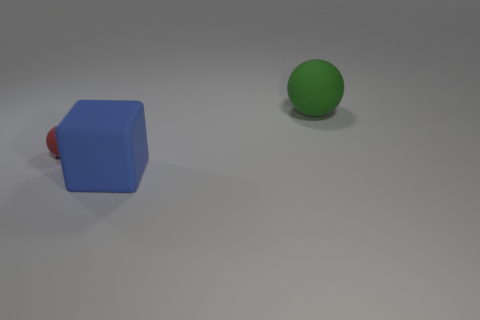There is another red ball that is made of the same material as the big ball; what is its size?
Give a very brief answer. Small. What material is the object behind the matte ball to the left of the big matte object that is behind the red matte sphere made of?
Keep it short and to the point. Rubber. How many metallic things are small red objects or small gray things?
Provide a succinct answer. 0. How many objects are big objects or objects on the left side of the green thing?
Make the answer very short. 3. There is a ball that is right of the blue rubber thing; does it have the same size as the blue rubber thing?
Provide a succinct answer. Yes. How many other objects are the same shape as the green matte object?
Keep it short and to the point. 1. What number of blue things are either big spheres or matte objects?
Ensure brevity in your answer.  1. There is a blue thing that is made of the same material as the big green object; what is its shape?
Offer a terse response. Cube. What is the color of the thing that is on the right side of the tiny thing and behind the blue matte block?
Provide a short and direct response. Green. How big is the ball in front of the large thing that is behind the big matte block?
Make the answer very short. Small. 